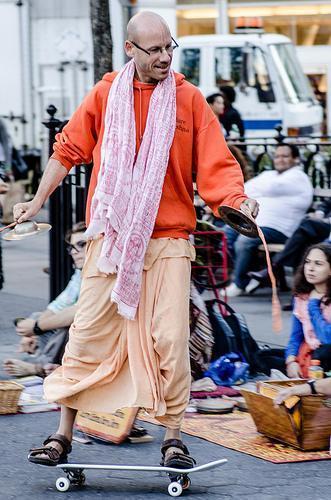How many cymbals is the man holding?
Give a very brief answer. 2. How many wheels does the skateboard have?
Give a very brief answer. 4. 